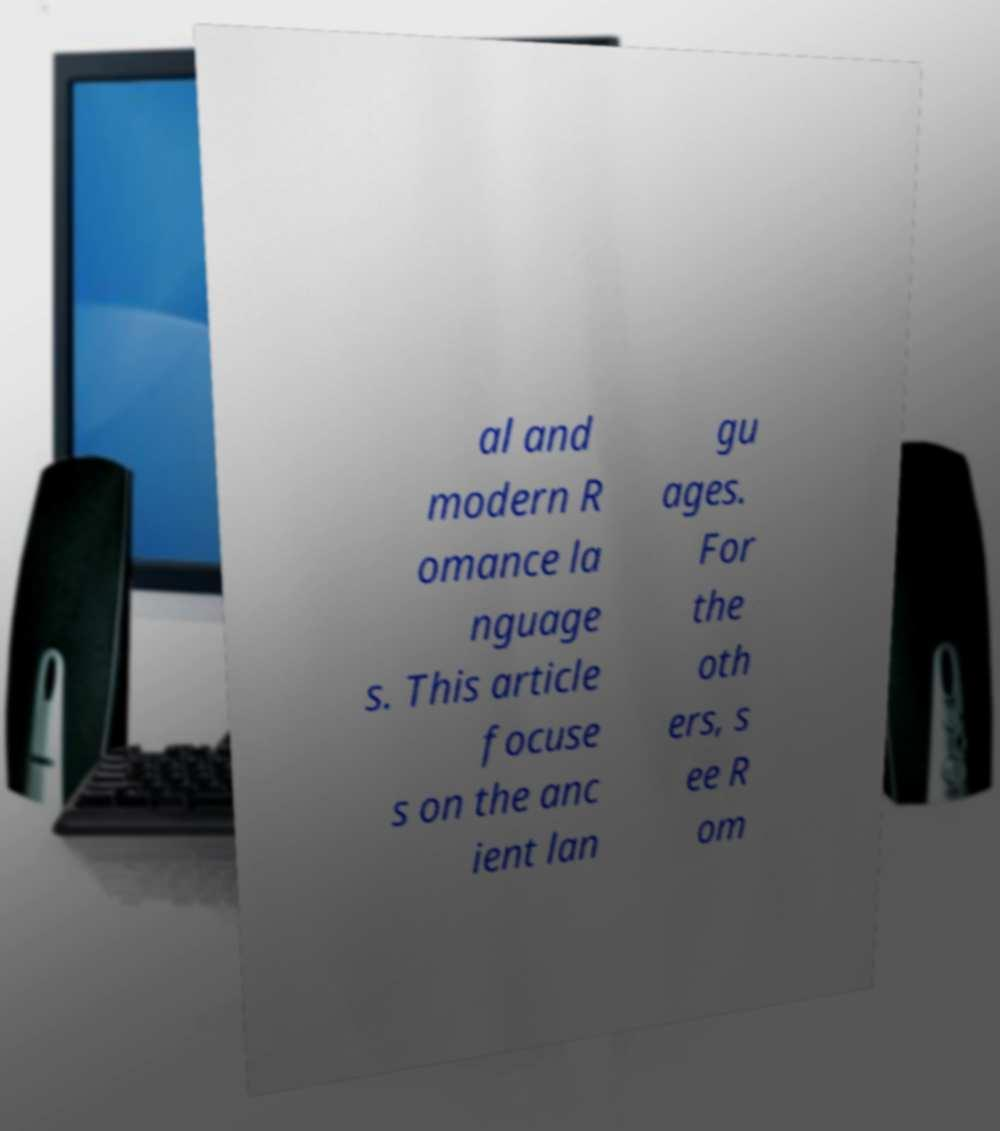Could you assist in decoding the text presented in this image and type it out clearly? al and modern R omance la nguage s. This article focuse s on the anc ient lan gu ages. For the oth ers, s ee R om 